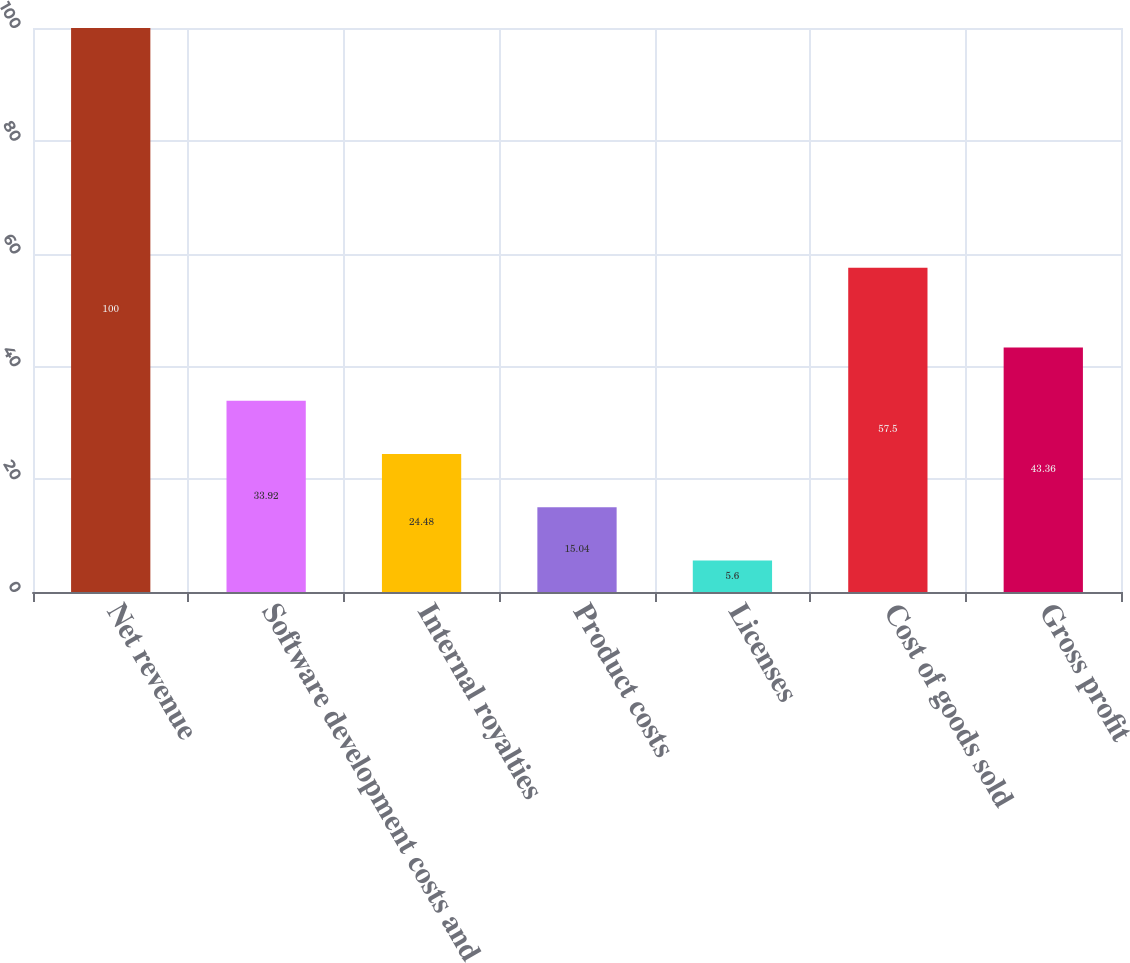Convert chart to OTSL. <chart><loc_0><loc_0><loc_500><loc_500><bar_chart><fcel>Net revenue<fcel>Software development costs and<fcel>Internal royalties<fcel>Product costs<fcel>Licenses<fcel>Cost of goods sold<fcel>Gross profit<nl><fcel>100<fcel>33.92<fcel>24.48<fcel>15.04<fcel>5.6<fcel>57.5<fcel>43.36<nl></chart> 